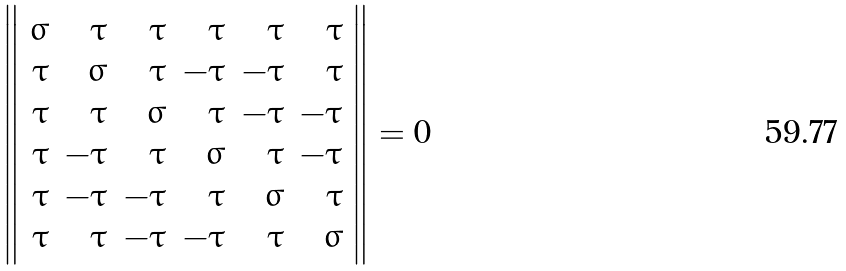Convert formula to latex. <formula><loc_0><loc_0><loc_500><loc_500>\left \| \begin{array} { r r r r r r } \sigma & \tau & \tau & \tau & \tau & \tau \\ \tau & \sigma & \tau & - \tau & - \tau & \tau \\ \tau & \tau & \sigma & \tau & - \tau & - \tau \\ \tau & - \tau & \tau & \sigma & \tau & - \tau \\ \tau & - \tau & - \tau & \tau & \sigma & \tau \\ \tau & \tau & - \tau & - \tau & \tau & \sigma \\ \end{array} \right \| = 0</formula> 